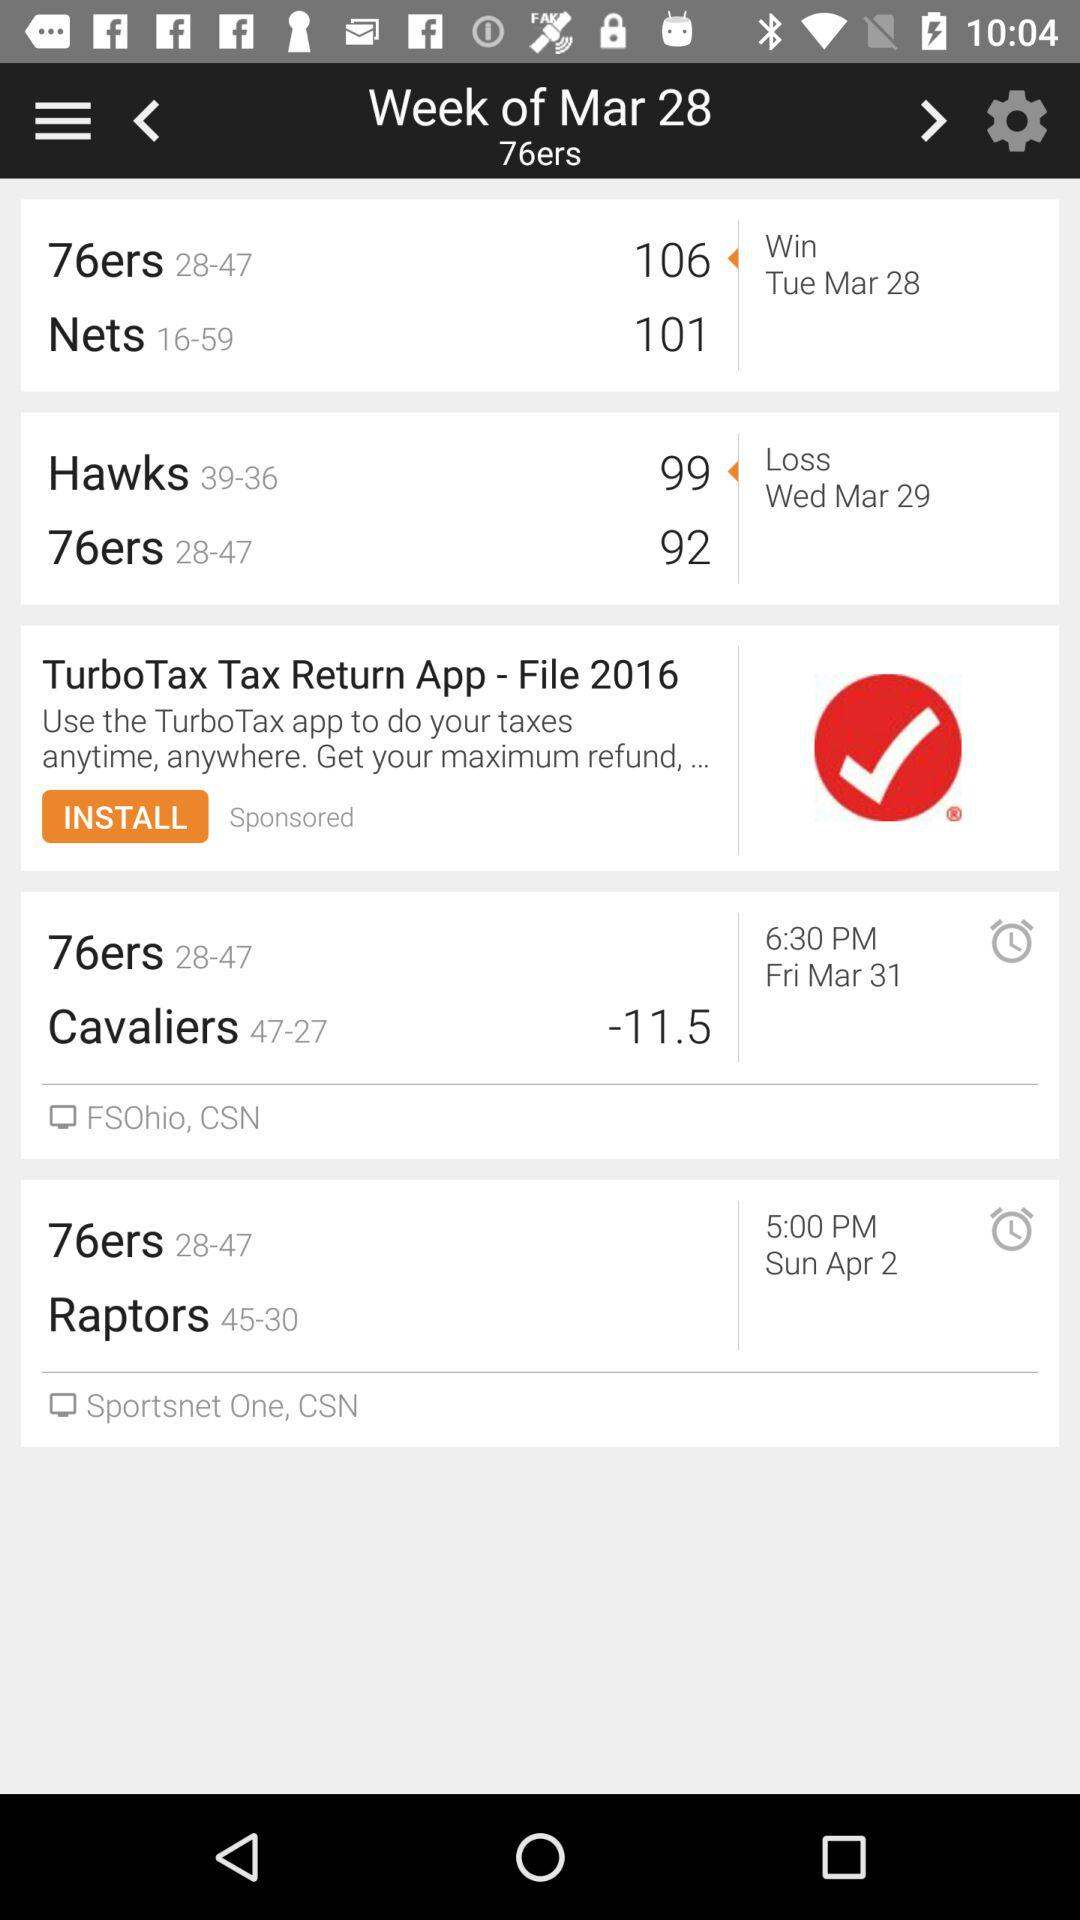What is the score of the "Nets" on March 28? The score is 101. 